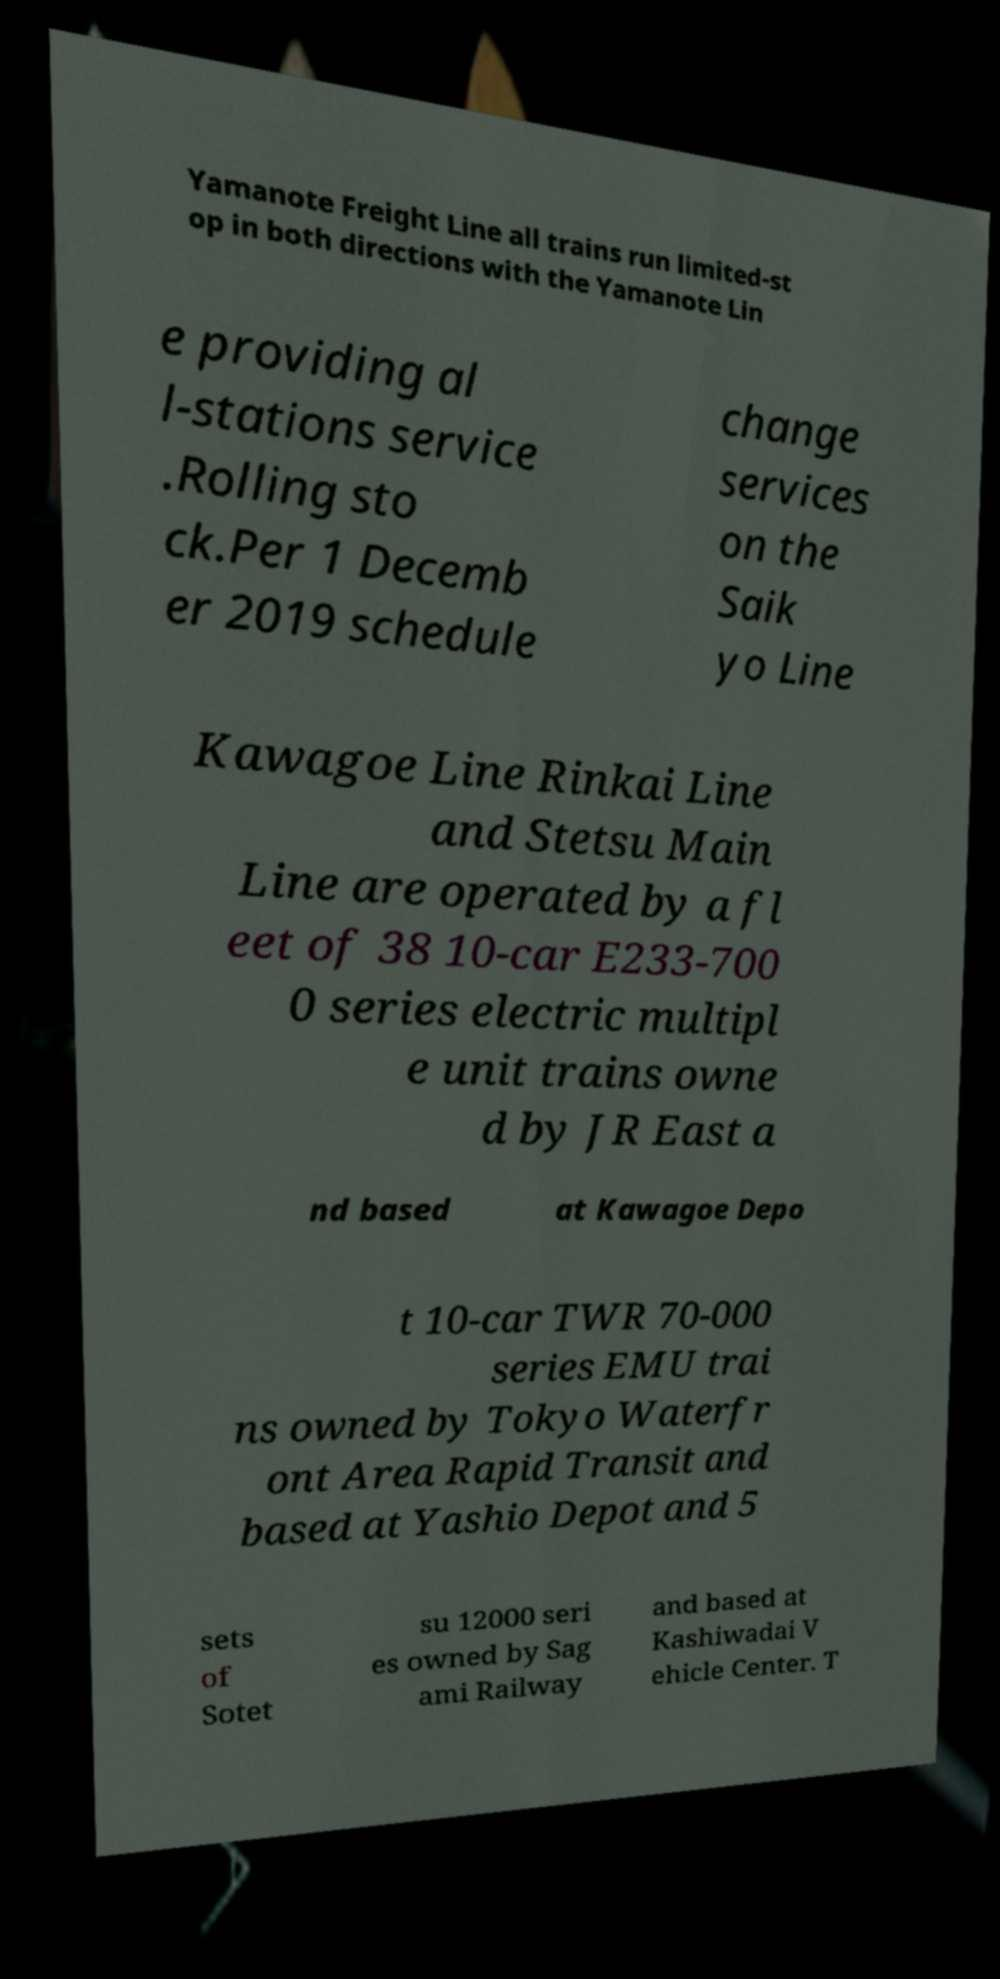Could you assist in decoding the text presented in this image and type it out clearly? Yamanote Freight Line all trains run limited-st op in both directions with the Yamanote Lin e providing al l-stations service .Rolling sto ck.Per 1 Decemb er 2019 schedule change services on the Saik yo Line Kawagoe Line Rinkai Line and Stetsu Main Line are operated by a fl eet of 38 10-car E233-700 0 series electric multipl e unit trains owne d by JR East a nd based at Kawagoe Depo t 10-car TWR 70-000 series EMU trai ns owned by Tokyo Waterfr ont Area Rapid Transit and based at Yashio Depot and 5 sets of Sotet su 12000 seri es owned by Sag ami Railway and based at Kashiwadai V ehicle Center. T 